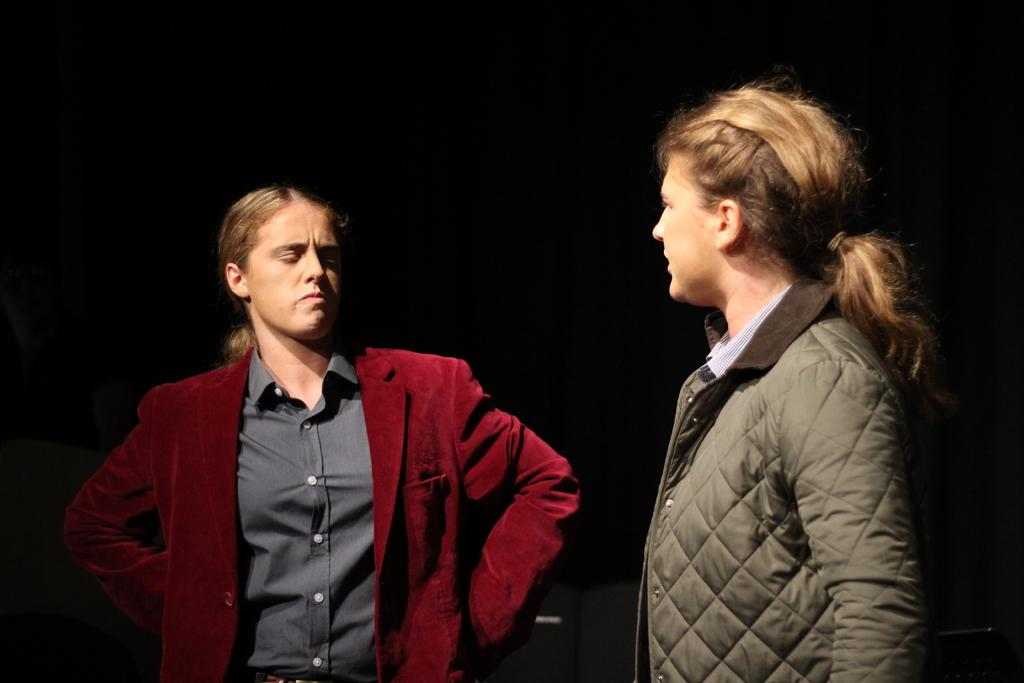How many people are in the image? There are two ladies in the image. What are the ladies wearing? The ladies are wearing jackets. What position are the ladies in? The ladies are standing. What color is the background of the image? The background of the image is black. What brand of toothpaste can be seen in the image? There is no toothpaste present in the image. Can you hear the ladies talking in the image? The image is a still photograph, so there is no sound or hearing involved. 